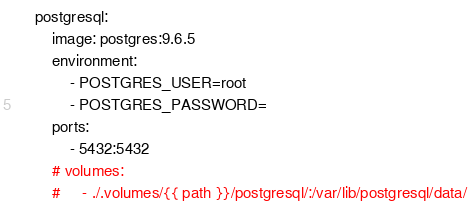Convert code to text. <code><loc_0><loc_0><loc_500><loc_500><_YAML_>    postgresql:
        image: postgres:9.6.5
        environment:
            - POSTGRES_USER=root
            - POSTGRES_PASSWORD=
        ports:
            - 5432:5432
        # volumes:
        #     - ./.volumes/{{ path }}/postgresql/:/var/lib/postgresql/data/
</code> 